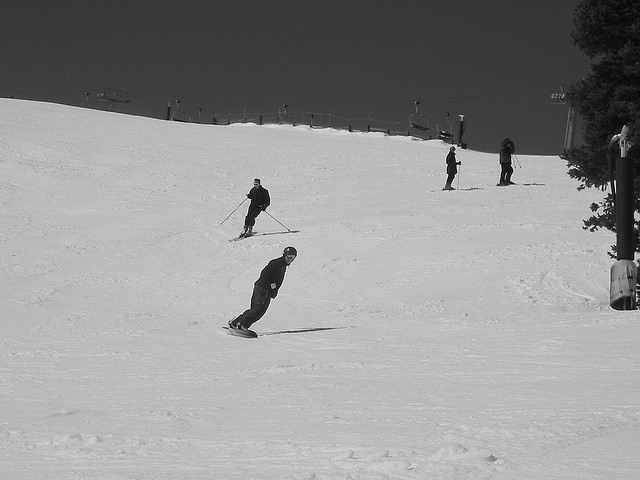Describe the objects in this image and their specific colors. I can see people in black, gray, darkgray, and lightgray tones, people in black, gray, darkgray, and gainsboro tones, people in black, gray, darkgray, and lightgray tones, people in black, gray, darkgray, and lightgray tones, and skis in black, lightgray, darkgray, and gray tones in this image. 